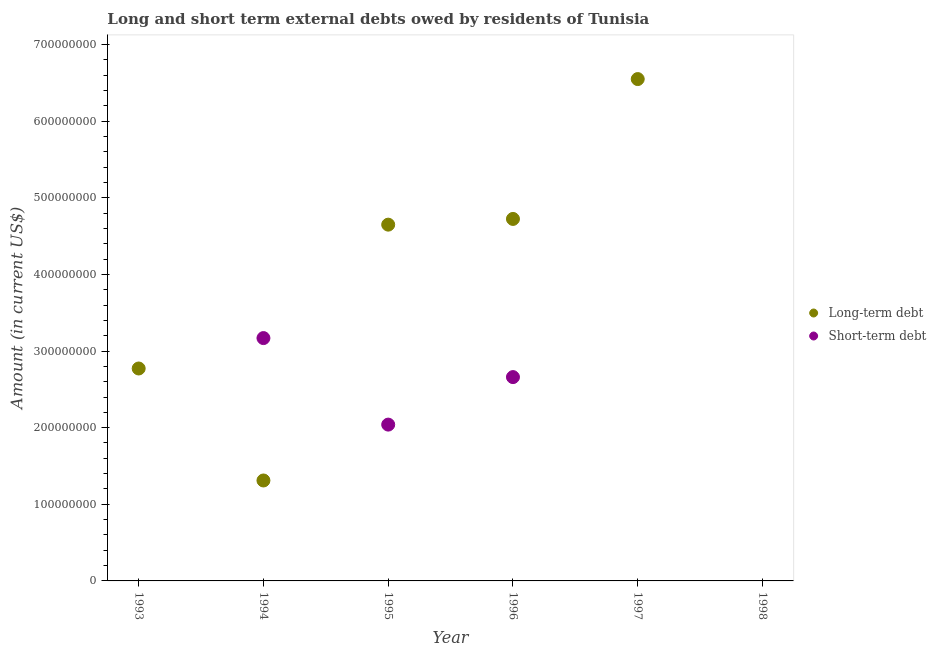What is the long-term debts owed by residents in 1996?
Offer a terse response. 4.72e+08. Across all years, what is the maximum long-term debts owed by residents?
Ensure brevity in your answer.  6.55e+08. What is the total short-term debts owed by residents in the graph?
Your answer should be compact. 7.87e+08. What is the difference between the long-term debts owed by residents in 1993 and that in 1994?
Provide a succinct answer. 1.46e+08. What is the difference between the short-term debts owed by residents in 1993 and the long-term debts owed by residents in 1995?
Your response must be concise. -4.65e+08. What is the average short-term debts owed by residents per year?
Give a very brief answer. 1.31e+08. In the year 1994, what is the difference between the long-term debts owed by residents and short-term debts owed by residents?
Offer a terse response. -1.86e+08. In how many years, is the short-term debts owed by residents greater than 580000000 US$?
Keep it short and to the point. 0. What is the ratio of the long-term debts owed by residents in 1995 to that in 1996?
Offer a terse response. 0.98. What is the difference between the highest and the second highest short-term debts owed by residents?
Your answer should be compact. 5.09e+07. What is the difference between the highest and the lowest long-term debts owed by residents?
Make the answer very short. 6.55e+08. In how many years, is the long-term debts owed by residents greater than the average long-term debts owed by residents taken over all years?
Your answer should be compact. 3. Is the sum of the long-term debts owed by residents in 1996 and 1997 greater than the maximum short-term debts owed by residents across all years?
Offer a very short reply. Yes. What is the difference between two consecutive major ticks on the Y-axis?
Provide a succinct answer. 1.00e+08. Where does the legend appear in the graph?
Give a very brief answer. Center right. How many legend labels are there?
Your response must be concise. 2. How are the legend labels stacked?
Make the answer very short. Vertical. What is the title of the graph?
Your answer should be very brief. Long and short term external debts owed by residents of Tunisia. Does "Primary school" appear as one of the legend labels in the graph?
Offer a very short reply. No. What is the label or title of the X-axis?
Offer a terse response. Year. What is the label or title of the Y-axis?
Your answer should be very brief. Amount (in current US$). What is the Amount (in current US$) in Long-term debt in 1993?
Offer a terse response. 2.77e+08. What is the Amount (in current US$) in Short-term debt in 1993?
Give a very brief answer. 0. What is the Amount (in current US$) of Long-term debt in 1994?
Provide a short and direct response. 1.31e+08. What is the Amount (in current US$) in Short-term debt in 1994?
Provide a succinct answer. 3.17e+08. What is the Amount (in current US$) of Long-term debt in 1995?
Your answer should be compact. 4.65e+08. What is the Amount (in current US$) of Short-term debt in 1995?
Your answer should be very brief. 2.04e+08. What is the Amount (in current US$) of Long-term debt in 1996?
Provide a succinct answer. 4.72e+08. What is the Amount (in current US$) of Short-term debt in 1996?
Provide a short and direct response. 2.66e+08. What is the Amount (in current US$) of Long-term debt in 1997?
Offer a very short reply. 6.55e+08. What is the Amount (in current US$) in Short-term debt in 1997?
Your response must be concise. 0. What is the Amount (in current US$) in Long-term debt in 1998?
Provide a short and direct response. 0. Across all years, what is the maximum Amount (in current US$) in Long-term debt?
Offer a very short reply. 6.55e+08. Across all years, what is the maximum Amount (in current US$) of Short-term debt?
Your answer should be compact. 3.17e+08. Across all years, what is the minimum Amount (in current US$) in Long-term debt?
Provide a short and direct response. 0. What is the total Amount (in current US$) of Long-term debt in the graph?
Your response must be concise. 2.00e+09. What is the total Amount (in current US$) of Short-term debt in the graph?
Ensure brevity in your answer.  7.87e+08. What is the difference between the Amount (in current US$) of Long-term debt in 1993 and that in 1994?
Your response must be concise. 1.46e+08. What is the difference between the Amount (in current US$) in Long-term debt in 1993 and that in 1995?
Your answer should be compact. -1.88e+08. What is the difference between the Amount (in current US$) of Long-term debt in 1993 and that in 1996?
Keep it short and to the point. -1.95e+08. What is the difference between the Amount (in current US$) of Long-term debt in 1993 and that in 1997?
Provide a succinct answer. -3.78e+08. What is the difference between the Amount (in current US$) in Long-term debt in 1994 and that in 1995?
Provide a short and direct response. -3.34e+08. What is the difference between the Amount (in current US$) of Short-term debt in 1994 and that in 1995?
Your answer should be compact. 1.13e+08. What is the difference between the Amount (in current US$) of Long-term debt in 1994 and that in 1996?
Your answer should be very brief. -3.41e+08. What is the difference between the Amount (in current US$) in Short-term debt in 1994 and that in 1996?
Make the answer very short. 5.09e+07. What is the difference between the Amount (in current US$) of Long-term debt in 1994 and that in 1997?
Give a very brief answer. -5.24e+08. What is the difference between the Amount (in current US$) in Long-term debt in 1995 and that in 1996?
Offer a very short reply. -7.46e+06. What is the difference between the Amount (in current US$) of Short-term debt in 1995 and that in 1996?
Your answer should be very brief. -6.20e+07. What is the difference between the Amount (in current US$) of Long-term debt in 1995 and that in 1997?
Ensure brevity in your answer.  -1.90e+08. What is the difference between the Amount (in current US$) in Long-term debt in 1996 and that in 1997?
Your response must be concise. -1.83e+08. What is the difference between the Amount (in current US$) of Long-term debt in 1993 and the Amount (in current US$) of Short-term debt in 1994?
Provide a succinct answer. -3.97e+07. What is the difference between the Amount (in current US$) in Long-term debt in 1993 and the Amount (in current US$) in Short-term debt in 1995?
Provide a succinct answer. 7.32e+07. What is the difference between the Amount (in current US$) of Long-term debt in 1993 and the Amount (in current US$) of Short-term debt in 1996?
Make the answer very short. 1.12e+07. What is the difference between the Amount (in current US$) of Long-term debt in 1994 and the Amount (in current US$) of Short-term debt in 1995?
Your answer should be compact. -7.29e+07. What is the difference between the Amount (in current US$) in Long-term debt in 1994 and the Amount (in current US$) in Short-term debt in 1996?
Your answer should be compact. -1.35e+08. What is the difference between the Amount (in current US$) in Long-term debt in 1995 and the Amount (in current US$) in Short-term debt in 1996?
Ensure brevity in your answer.  1.99e+08. What is the average Amount (in current US$) in Long-term debt per year?
Provide a short and direct response. 3.33e+08. What is the average Amount (in current US$) of Short-term debt per year?
Your response must be concise. 1.31e+08. In the year 1994, what is the difference between the Amount (in current US$) in Long-term debt and Amount (in current US$) in Short-term debt?
Ensure brevity in your answer.  -1.86e+08. In the year 1995, what is the difference between the Amount (in current US$) of Long-term debt and Amount (in current US$) of Short-term debt?
Provide a short and direct response. 2.61e+08. In the year 1996, what is the difference between the Amount (in current US$) of Long-term debt and Amount (in current US$) of Short-term debt?
Ensure brevity in your answer.  2.06e+08. What is the ratio of the Amount (in current US$) in Long-term debt in 1993 to that in 1994?
Offer a very short reply. 2.12. What is the ratio of the Amount (in current US$) of Long-term debt in 1993 to that in 1995?
Give a very brief answer. 0.6. What is the ratio of the Amount (in current US$) in Long-term debt in 1993 to that in 1996?
Give a very brief answer. 0.59. What is the ratio of the Amount (in current US$) in Long-term debt in 1993 to that in 1997?
Your response must be concise. 0.42. What is the ratio of the Amount (in current US$) in Long-term debt in 1994 to that in 1995?
Offer a very short reply. 0.28. What is the ratio of the Amount (in current US$) in Short-term debt in 1994 to that in 1995?
Keep it short and to the point. 1.55. What is the ratio of the Amount (in current US$) of Long-term debt in 1994 to that in 1996?
Provide a short and direct response. 0.28. What is the ratio of the Amount (in current US$) in Short-term debt in 1994 to that in 1996?
Your response must be concise. 1.19. What is the ratio of the Amount (in current US$) in Long-term debt in 1994 to that in 1997?
Give a very brief answer. 0.2. What is the ratio of the Amount (in current US$) of Long-term debt in 1995 to that in 1996?
Give a very brief answer. 0.98. What is the ratio of the Amount (in current US$) of Short-term debt in 1995 to that in 1996?
Your answer should be compact. 0.77. What is the ratio of the Amount (in current US$) of Long-term debt in 1995 to that in 1997?
Your answer should be compact. 0.71. What is the ratio of the Amount (in current US$) of Long-term debt in 1996 to that in 1997?
Offer a terse response. 0.72. What is the difference between the highest and the second highest Amount (in current US$) in Long-term debt?
Make the answer very short. 1.83e+08. What is the difference between the highest and the second highest Amount (in current US$) of Short-term debt?
Provide a short and direct response. 5.09e+07. What is the difference between the highest and the lowest Amount (in current US$) of Long-term debt?
Make the answer very short. 6.55e+08. What is the difference between the highest and the lowest Amount (in current US$) of Short-term debt?
Ensure brevity in your answer.  3.17e+08. 